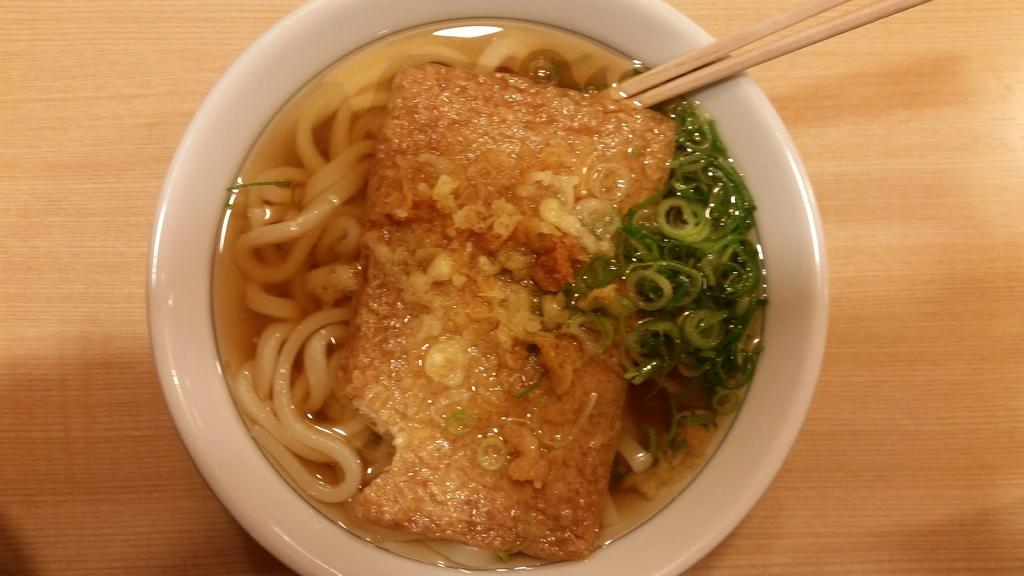What is in the bowl that is visible in the image? The bowl contains liquid, noodles, vegetable pieces, and sticks. What type of food is represented by the sticks in the bowl? The sticks in the bowl are likely chopsticks, which are used for eating noodles. Where is the bowl located in the image? The bowl is placed on a table. What other items might be present on the table, based on the presence of the bowl? It is not possible to determine what other items might be present on the table from the information provided. How many oranges are visible in the image? There are no oranges present in the image. 